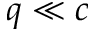Convert formula to latex. <formula><loc_0><loc_0><loc_500><loc_500>q \ll c</formula> 